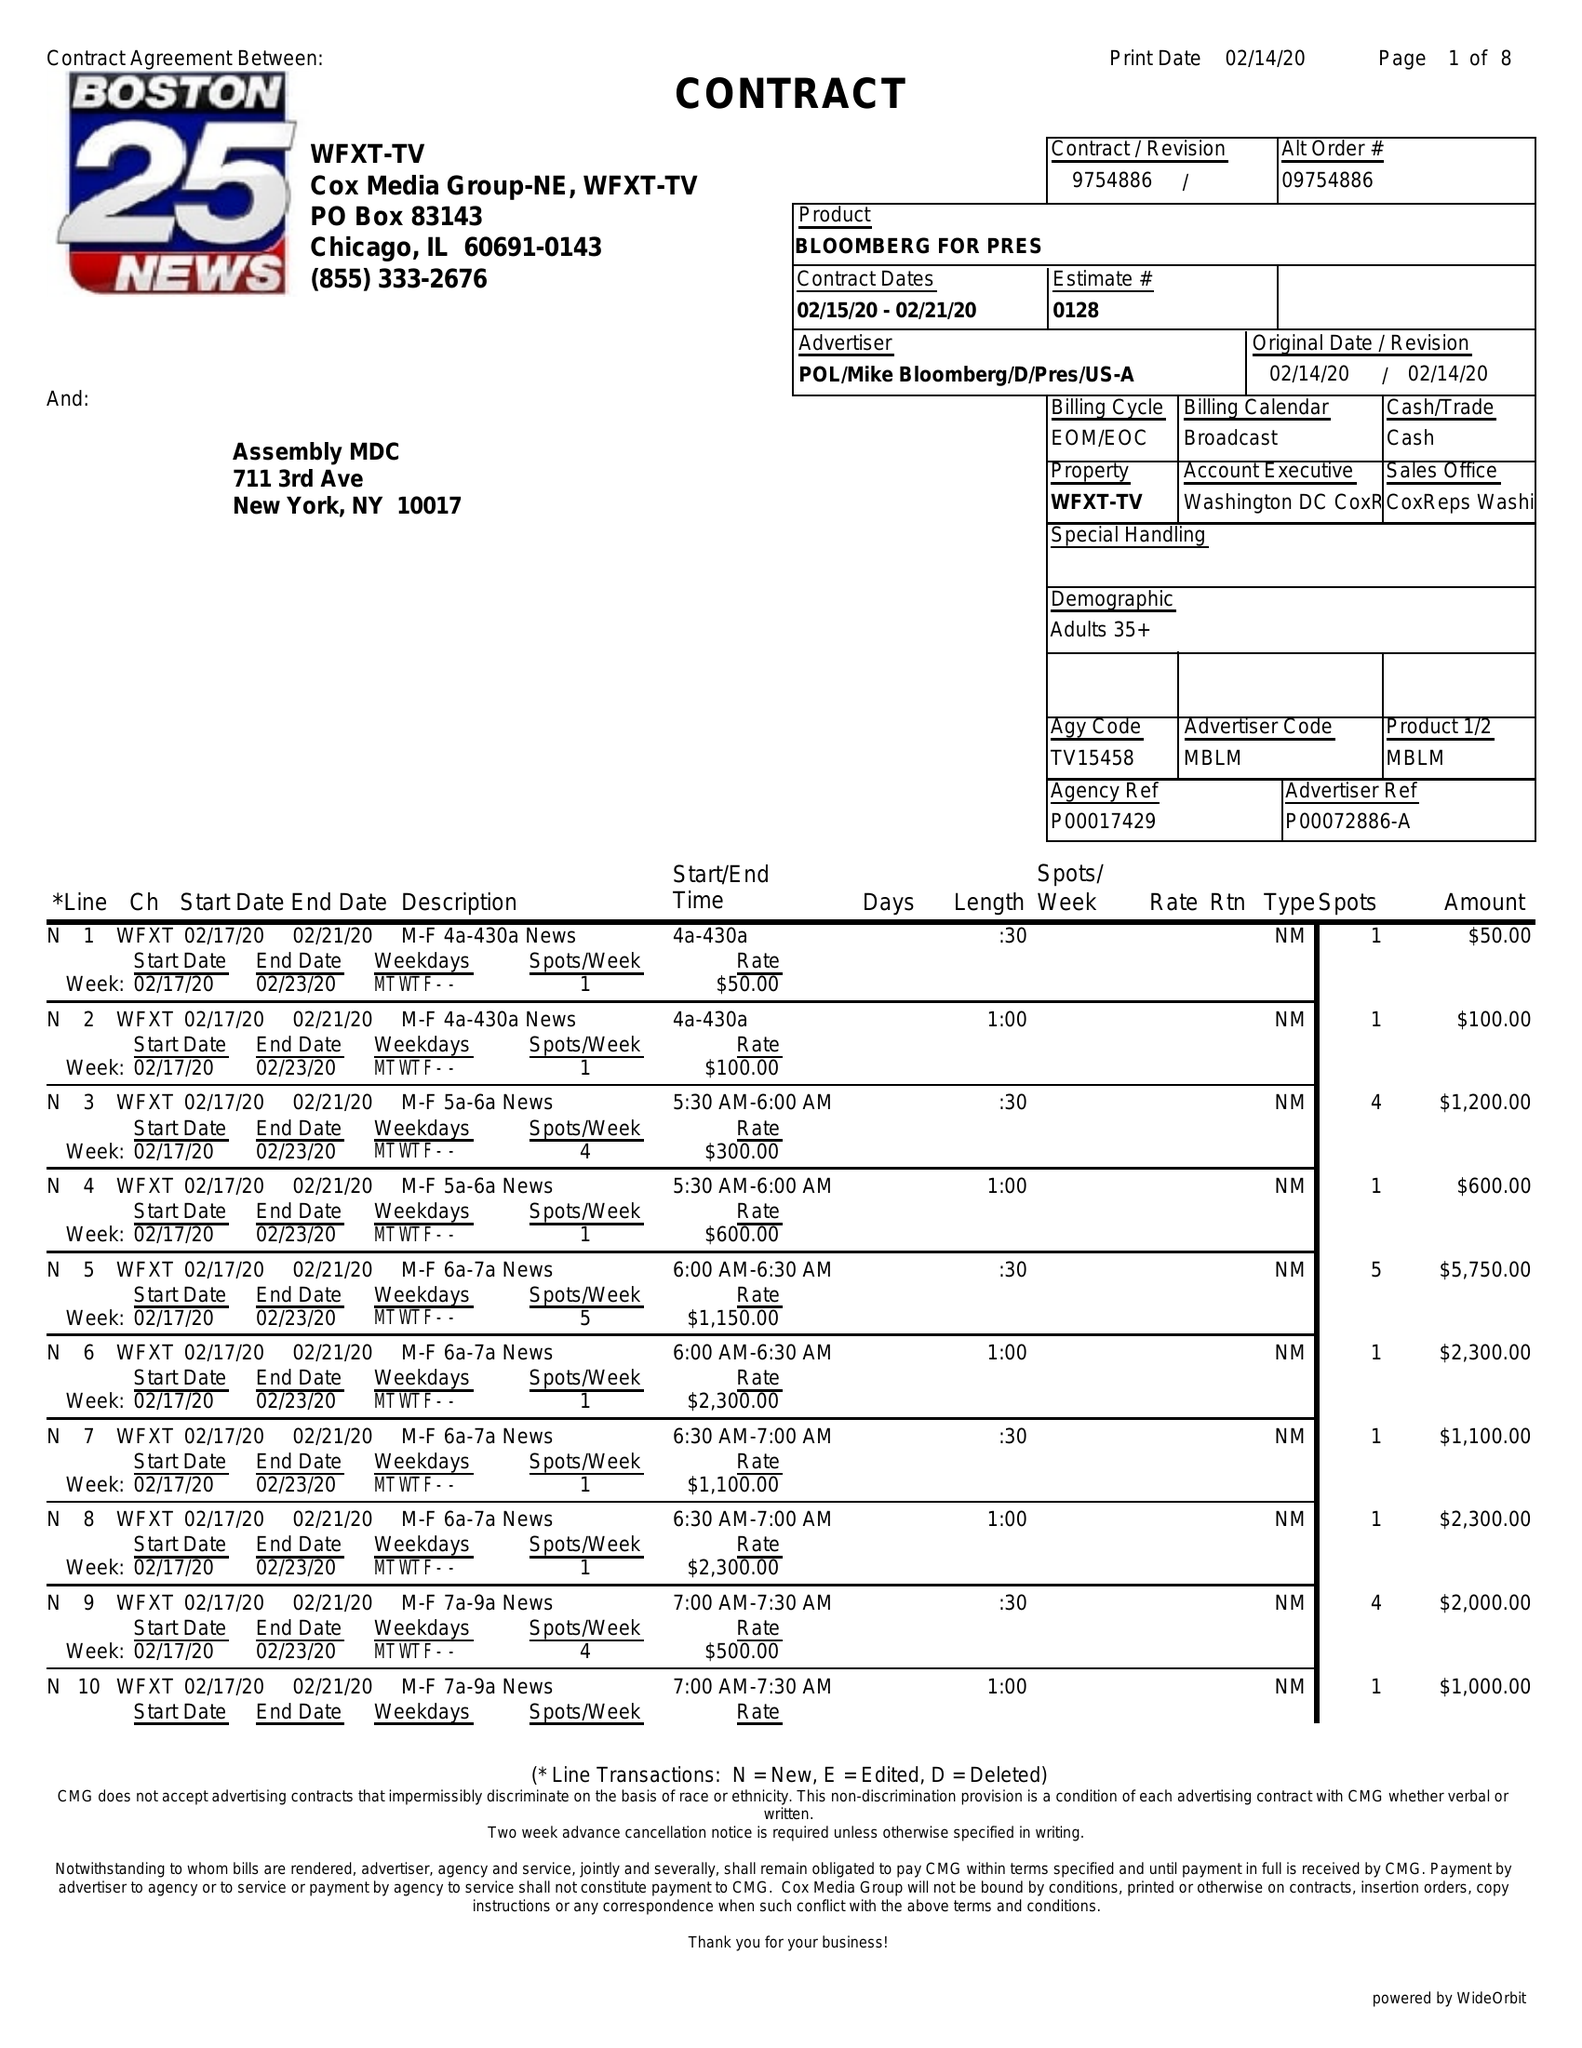What is the value for the contract_num?
Answer the question using a single word or phrase. 9754886 